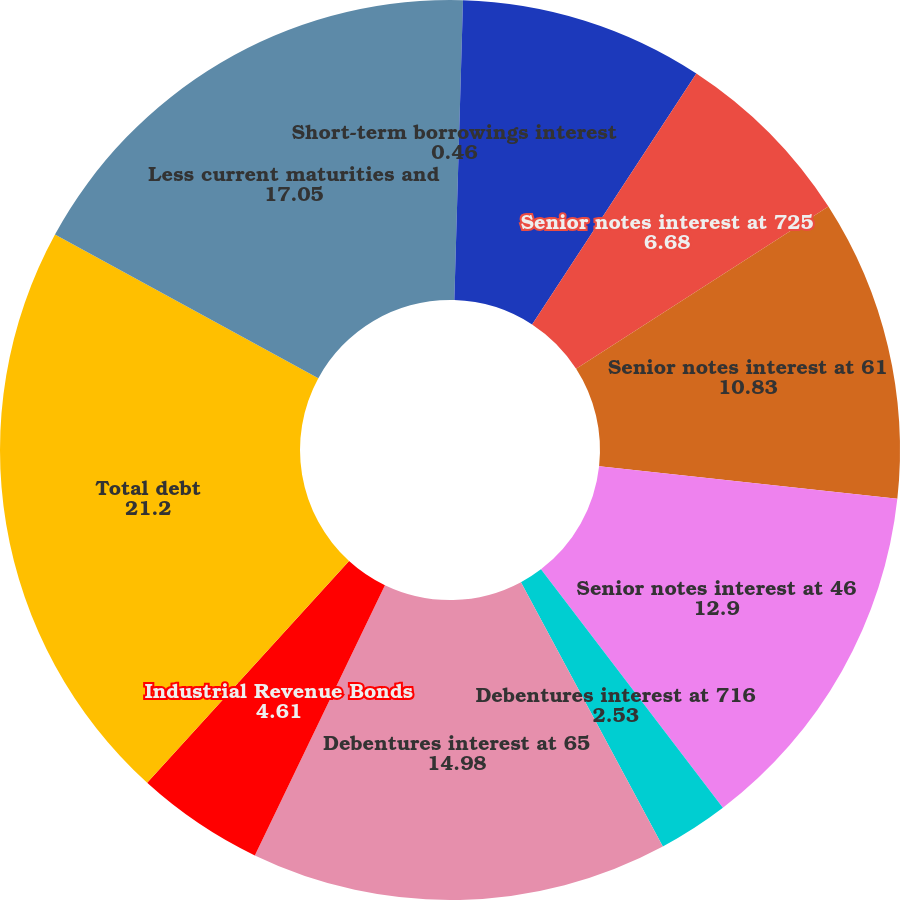<chart> <loc_0><loc_0><loc_500><loc_500><pie_chart><fcel>Short-term borrowings interest<fcel>Commercial paper interest<fcel>Senior notes interest at 725<fcel>Senior notes interest at 61<fcel>Senior notes interest at 46<fcel>Debentures interest at 716<fcel>Debentures interest at 65<fcel>Industrial Revenue Bonds<fcel>Total debt<fcel>Less current maturities and<nl><fcel>0.46%<fcel>8.76%<fcel>6.68%<fcel>10.83%<fcel>12.9%<fcel>2.53%<fcel>14.98%<fcel>4.61%<fcel>21.2%<fcel>17.05%<nl></chart> 